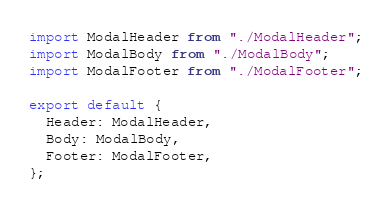<code> <loc_0><loc_0><loc_500><loc_500><_JavaScript_>import ModalHeader from "./ModalHeader";
import ModalBody from "./ModalBody";
import ModalFooter from "./ModalFooter";

export default {
  Header: ModalHeader,
  Body: ModalBody,
  Footer: ModalFooter,
};
</code> 